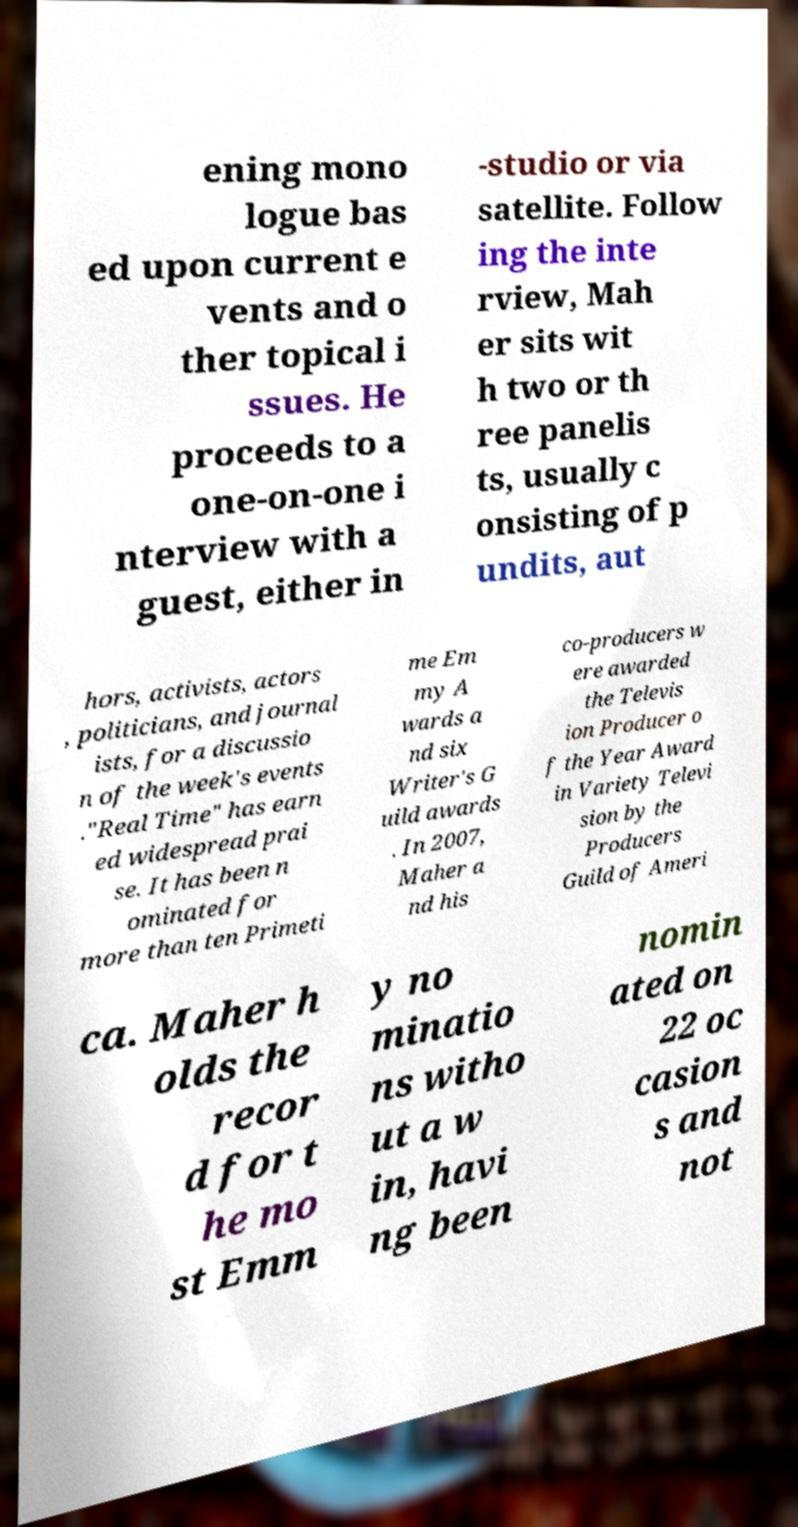Please identify and transcribe the text found in this image. ening mono logue bas ed upon current e vents and o ther topical i ssues. He proceeds to a one-on-one i nterview with a guest, either in -studio or via satellite. Follow ing the inte rview, Mah er sits wit h two or th ree panelis ts, usually c onsisting of p undits, aut hors, activists, actors , politicians, and journal ists, for a discussio n of the week's events ."Real Time" has earn ed widespread prai se. It has been n ominated for more than ten Primeti me Em my A wards a nd six Writer's G uild awards . In 2007, Maher a nd his co-producers w ere awarded the Televis ion Producer o f the Year Award in Variety Televi sion by the Producers Guild of Ameri ca. Maher h olds the recor d for t he mo st Emm y no minatio ns witho ut a w in, havi ng been nomin ated on 22 oc casion s and not 